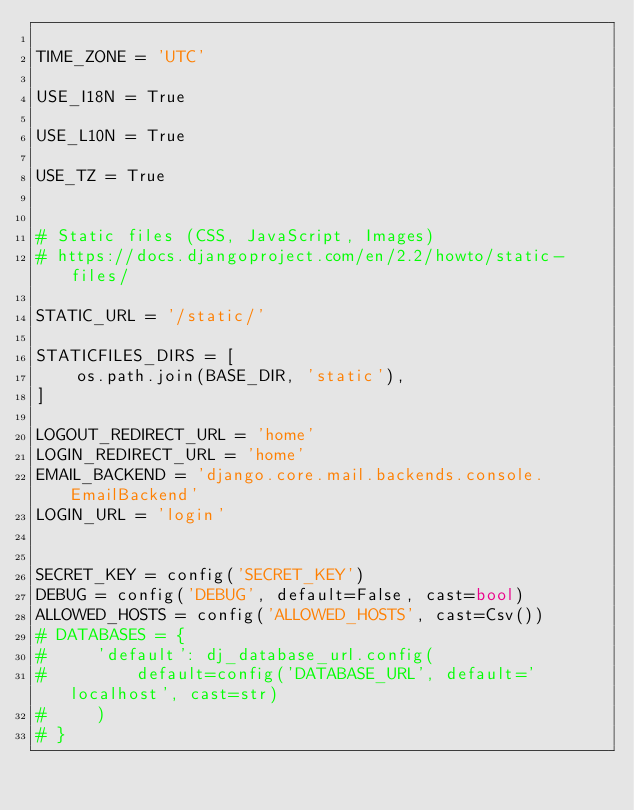<code> <loc_0><loc_0><loc_500><loc_500><_Python_>
TIME_ZONE = 'UTC'

USE_I18N = True

USE_L10N = True

USE_TZ = True


# Static files (CSS, JavaScript, Images)
# https://docs.djangoproject.com/en/2.2/howto/static-files/

STATIC_URL = '/static/'

STATICFILES_DIRS = [
    os.path.join(BASE_DIR, 'static'),
]

LOGOUT_REDIRECT_URL = 'home'
LOGIN_REDIRECT_URL = 'home'
EMAIL_BACKEND = 'django.core.mail.backends.console.EmailBackend'
LOGIN_URL = 'login'


SECRET_KEY = config('SECRET_KEY')
DEBUG = config('DEBUG', default=False, cast=bool)
ALLOWED_HOSTS = config('ALLOWED_HOSTS', cast=Csv())
# DATABASES = {
#     'default': dj_database_url.config(
#         default=config('DATABASE_URL', default='localhost', cast=str)
#     )
# }
</code> 